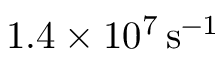<formula> <loc_0><loc_0><loc_500><loc_500>1 . 4 \times 1 0 ^ { 7 } \, s ^ { - 1 }</formula> 